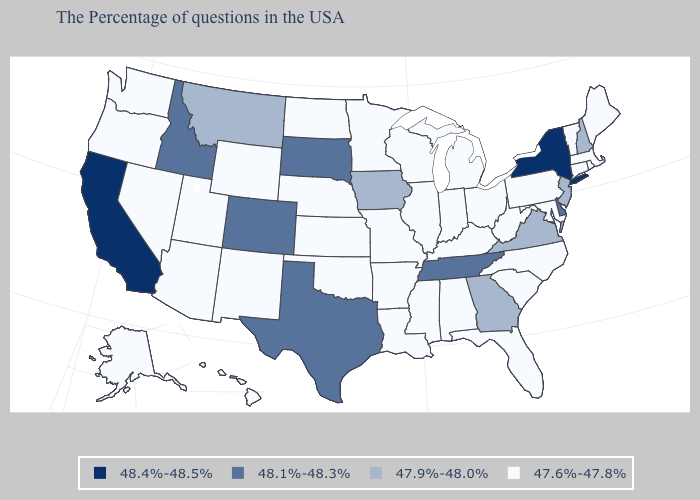What is the value of Pennsylvania?
Quick response, please. 47.6%-47.8%. Name the states that have a value in the range 47.9%-48.0%?
Concise answer only. New Hampshire, New Jersey, Virginia, Georgia, Iowa, Montana. Among the states that border Kentucky , does Tennessee have the highest value?
Be succinct. Yes. Is the legend a continuous bar?
Be succinct. No. What is the highest value in the USA?
Keep it brief. 48.4%-48.5%. Name the states that have a value in the range 48.1%-48.3%?
Write a very short answer. Delaware, Tennessee, Texas, South Dakota, Colorado, Idaho. Among the states that border Delaware , does Pennsylvania have the lowest value?
Write a very short answer. Yes. How many symbols are there in the legend?
Give a very brief answer. 4. Among the states that border New York , which have the lowest value?
Keep it brief. Massachusetts, Vermont, Connecticut, Pennsylvania. Is the legend a continuous bar?
Give a very brief answer. No. What is the lowest value in states that border New York?
Give a very brief answer. 47.6%-47.8%. What is the value of Wisconsin?
Answer briefly. 47.6%-47.8%. Is the legend a continuous bar?
Be succinct. No. What is the value of Florida?
Answer briefly. 47.6%-47.8%. 